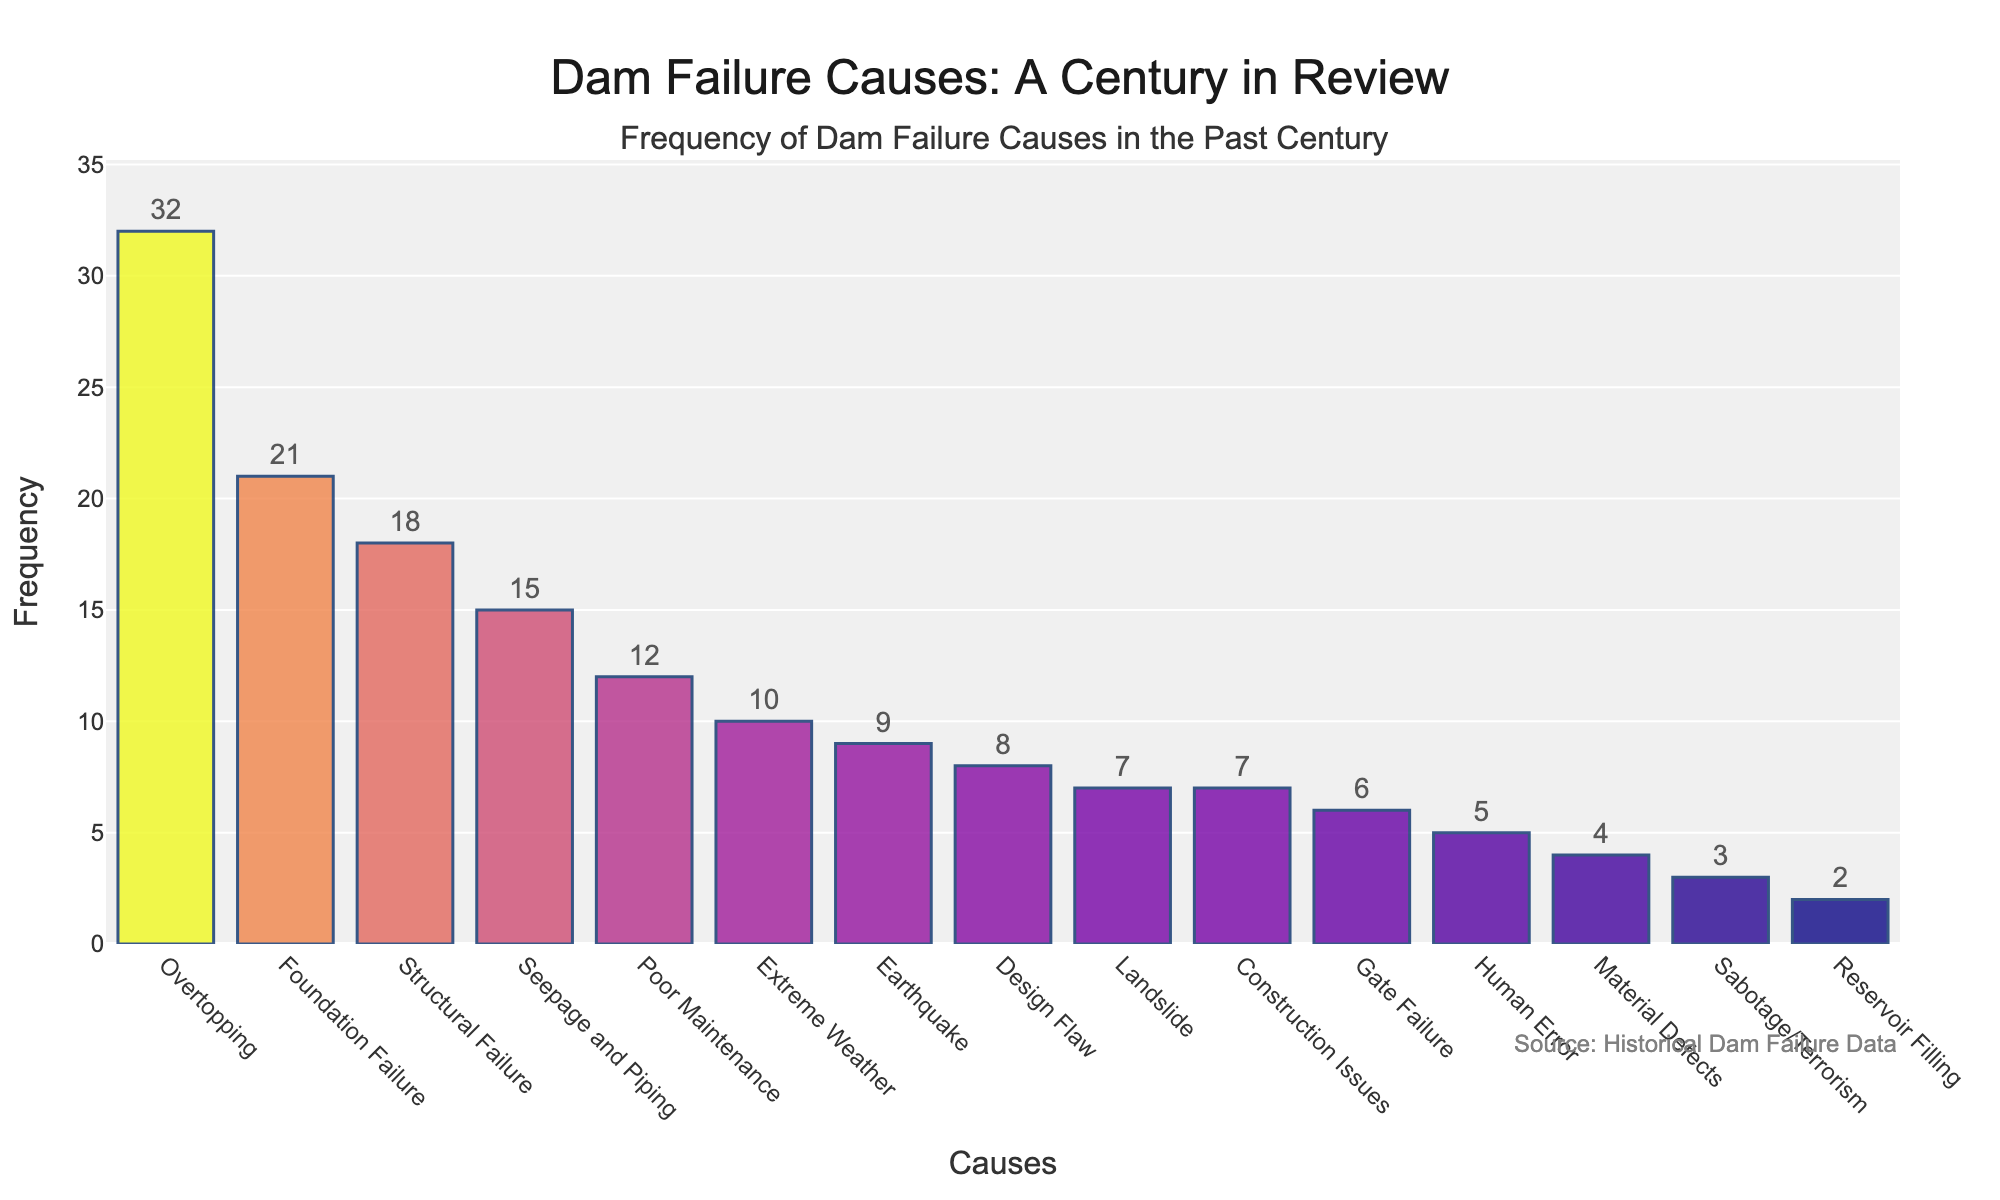Which cause has the highest frequency of dam failures? The cause with the highest bar represents the highest frequency. Overtopping has the tallest bar.
Answer: Overtopping Which cause has the lowest frequency of dam failures? The cause with the shortest bar represents the lowest frequency. Reservoir Filling has the shortest bar.
Answer: Reservoir Filling What is the combined frequency of dam failures caused by Seepage and Piping, Earthquake, and Landslide? Sum the frequencies of Seepage and Piping (15), Earthquake (9), and Landslide (7). 15 + 9 + 7 = 31.
Answer: 31 How does the frequency of Structural Failure compare to Poor Maintenance? Compare the heights of the bars corresponding to Structural Failure and Poor Maintenance. Structural Failure has a frequency of 18, and Poor Maintenance has a frequency of 12. Therefore, Structural Failure is higher.
Answer: Higher Which two causes have an equal frequency of dam failures? Look for two bars of equal height. Landslide and Construction Issues each have a frequency of 7.
Answer: Landslide and Construction Issues What is the percentage representation of Overtopping in the total number of dam failures? First, calculate the total frequency sum of all causes, which is 159. Then calculate the percentage: (32 / 159) * 100 ≈ 20.13%.
Answer: ~20.13% Which cause has a frequency closest to the average frequency of all causes? Calculate the average frequency by dividing the total frequency by the number of causes. 159 / 15 ≈ 10.6. The cause with frequency closest to 10.6 is Extreme Weather with a frequency of 10.
Answer: Extreme Weather How much higher is the frequency of Design Flaw compared to Material Defects? Subtract the frequency of Material Defects (4) from Design Flaw (8). 8 - 4 = 4.
Answer: 4 What is the visual color difference between the bars representing the highest and lowest frequencies? The bar for Overtopping (highest frequency) has a darker shade compared to the bar for Reservoir Filling (lowest frequency), which has a lighter shade.
Answer: Darker vs Lighter What is the total frequency of dam failures caused by human-related factors (Human Error, Sabotage/Terrorism, and Poor Maintenance)? Sum the frequencies of Human Error (5), Sabotage/Terrorism (3), and Poor Maintenance (12). 5 + 3 + 12 = 20.
Answer: 20 